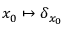<formula> <loc_0><loc_0><loc_500><loc_500>x _ { 0 } \mapsto \delta _ { x _ { 0 } }</formula> 